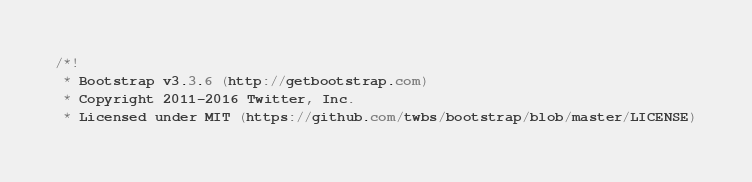<code> <loc_0><loc_0><loc_500><loc_500><_CSS_>/*!
 * Bootstrap v3.3.6 (http://getbootstrap.com)
 * Copyright 2011-2016 Twitter, Inc.
 * Licensed under MIT (https://github.com/twbs/bootstrap/blob/master/LICENSE)</code> 